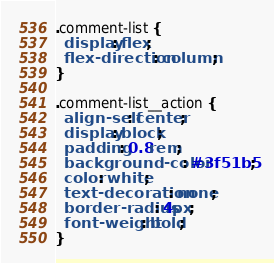<code> <loc_0><loc_0><loc_500><loc_500><_CSS_>.comment-list {
  display: flex;
  flex-direction: column;
}

.comment-list__action {
  align-self: center;
  display: block;
  padding: 0.8rem;
  background-color: #3f51b5;
  color: white;
  text-decoration: none;
  border-radius: 4px;
  font-weight: bold;
}
</code> 